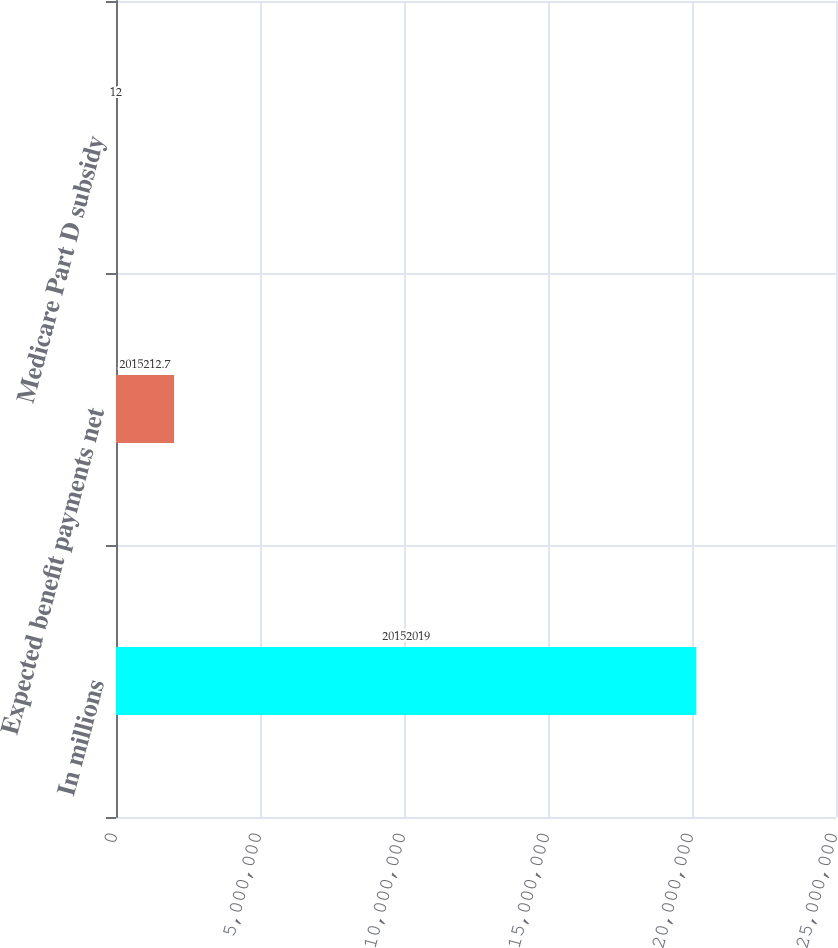Convert chart. <chart><loc_0><loc_0><loc_500><loc_500><bar_chart><fcel>In millions<fcel>Expected benefit payments net<fcel>Medicare Part D subsidy<nl><fcel>2.0152e+07<fcel>2.01521e+06<fcel>12<nl></chart> 